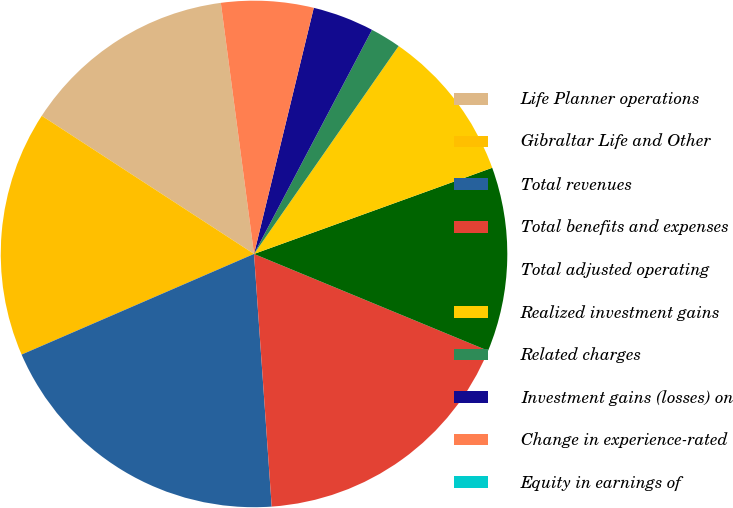Convert chart. <chart><loc_0><loc_0><loc_500><loc_500><pie_chart><fcel>Life Planner operations<fcel>Gibraltar Life and Other<fcel>Total revenues<fcel>Total benefits and expenses<fcel>Total adjusted operating<fcel>Realized investment gains<fcel>Related charges<fcel>Investment gains (losses) on<fcel>Change in experience-rated<fcel>Equity in earnings of<nl><fcel>13.72%<fcel>15.68%<fcel>19.6%<fcel>17.64%<fcel>11.76%<fcel>9.8%<fcel>1.96%<fcel>3.92%<fcel>5.88%<fcel>0.0%<nl></chart> 